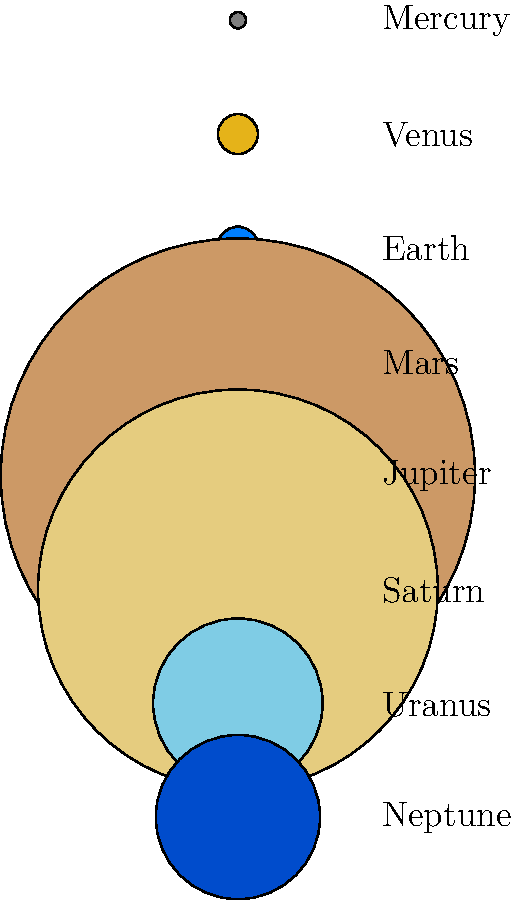Let's say you're planning a kitesurfing expedition across the solar system. If Earth's diameter is approximately 12,756 km, which planet would offer you about 11 times more surface area to kitesurf on? To find the planet with 11 times more surface area than Earth, we need to follow these steps:

1. Recall the formula for the surface area of a sphere: $A = 4\pi r^2$, where $r$ is the radius.

2. Earth's diameter is 12,756 km, so its radius is 6,378 km.

3. Calculate Earth's surface area:
   $A_{Earth} = 4\pi (6,378)^2 \approx 511,185,932 \text{ km}^2$

4. The planet we're looking for should have 11 times this surface area:
   $A_{target} = 11 \times 511,185,932 \approx 5,623,045,252 \text{ km}^2$

5. Using the surface area formula, we can find the radius of this planet:
   $5,623,045,252 = 4\pi r^2$
   $r^2 = 5,623,045,252 / (4\pi) \approx 447,315,723$
   $r \approx 21,150 \text{ km}$

6. The diameter of this planet would be about 42,300 km.

7. Looking at the diagram, Jupiter has a diameter of 142,984 km, which is closest to our calculated value and about 11.2 times larger than Earth.

Therefore, Jupiter is the planet that would offer about 11 times more surface area for kitesurfing compared to Earth.
Answer: Jupiter 